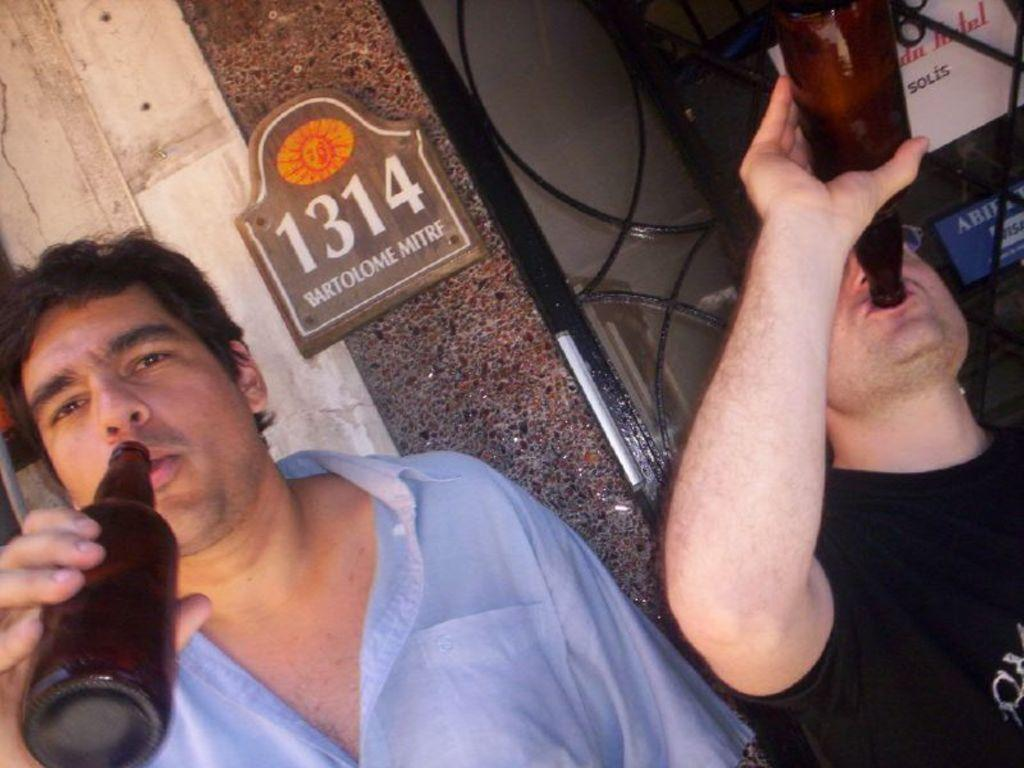Who is present in the image? There are men in the image. What are the men doing in the image? The men are standing in the image. What objects are the men holding in their hands? The men are holding wine bottles in their hands. What type of son can be seen playing with a unit in the image? There is no son or unit present in the image; it features men holding wine bottles. 